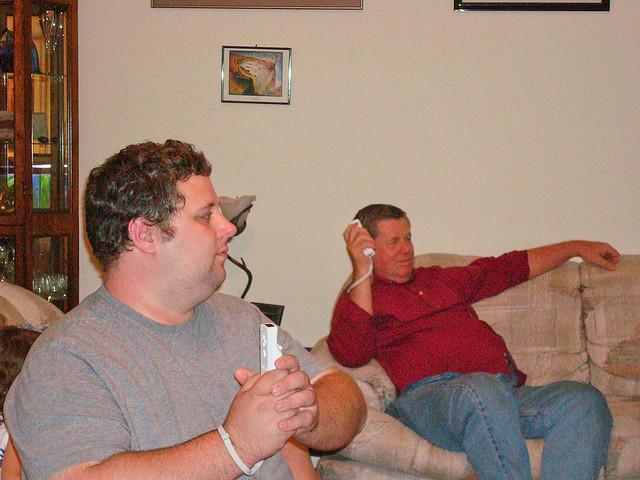What are the two men doing together? playing wii 